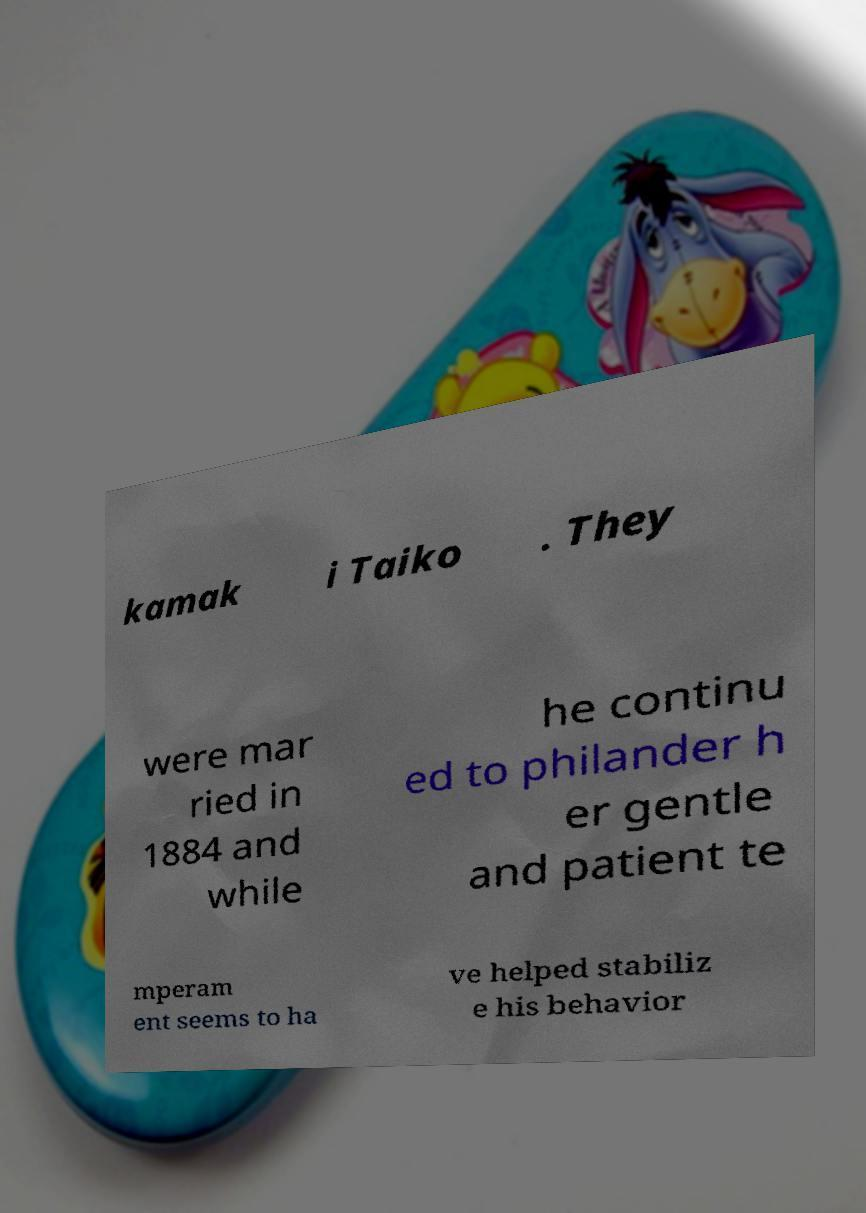Can you read and provide the text displayed in the image?This photo seems to have some interesting text. Can you extract and type it out for me? kamak i Taiko . They were mar ried in 1884 and while he continu ed to philander h er gentle and patient te mperam ent seems to ha ve helped stabiliz e his behavior 